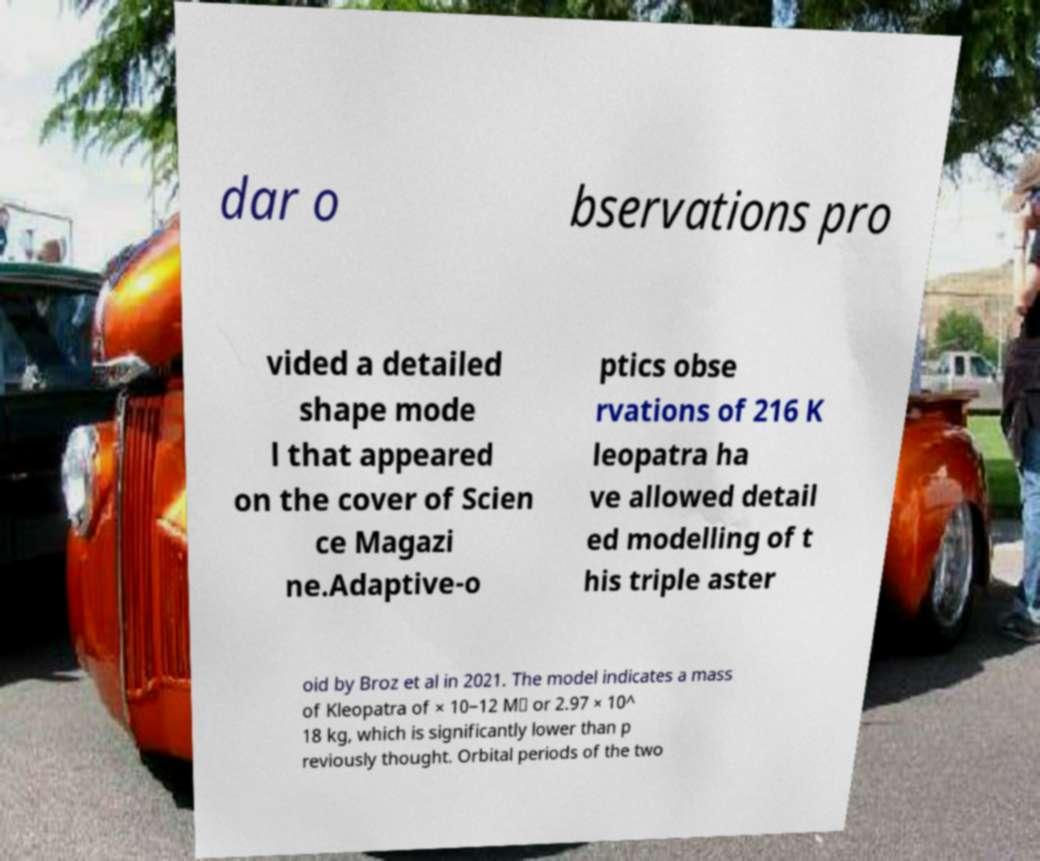I need the written content from this picture converted into text. Can you do that? dar o bservations pro vided a detailed shape mode l that appeared on the cover of Scien ce Magazi ne.Adaptive-o ptics obse rvations of 216 K leopatra ha ve allowed detail ed modelling of t his triple aster oid by Broz et al in 2021. The model indicates a mass of Kleopatra of × 10−12 M⊙ or 2.97 × 10^ 18 kg, which is significantly lower than p reviously thought. Orbital periods of the two 